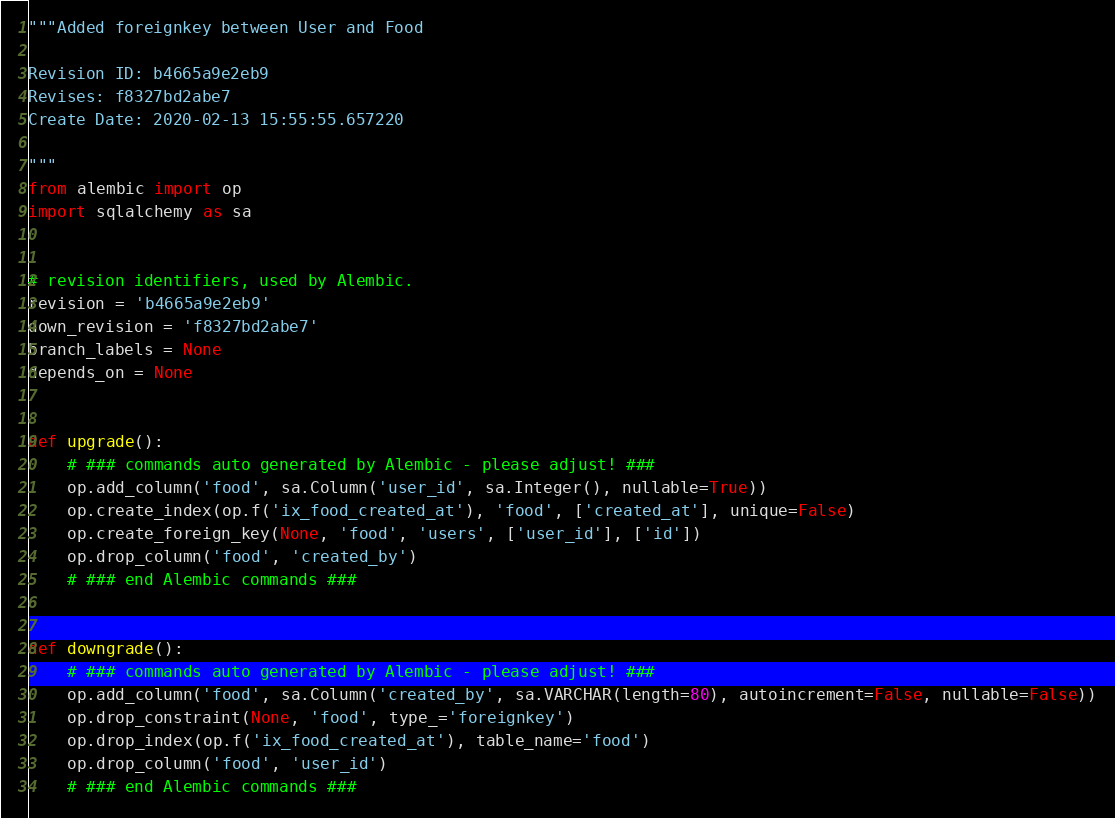<code> <loc_0><loc_0><loc_500><loc_500><_Python_>"""Added foreignkey between User and Food

Revision ID: b4665a9e2eb9
Revises: f8327bd2abe7
Create Date: 2020-02-13 15:55:55.657220

"""
from alembic import op
import sqlalchemy as sa


# revision identifiers, used by Alembic.
revision = 'b4665a9e2eb9'
down_revision = 'f8327bd2abe7'
branch_labels = None
depends_on = None


def upgrade():
    # ### commands auto generated by Alembic - please adjust! ###
    op.add_column('food', sa.Column('user_id', sa.Integer(), nullable=True))
    op.create_index(op.f('ix_food_created_at'), 'food', ['created_at'], unique=False)
    op.create_foreign_key(None, 'food', 'users', ['user_id'], ['id'])
    op.drop_column('food', 'created_by')
    # ### end Alembic commands ###


def downgrade():
    # ### commands auto generated by Alembic - please adjust! ###
    op.add_column('food', sa.Column('created_by', sa.VARCHAR(length=80), autoincrement=False, nullable=False))
    op.drop_constraint(None, 'food', type_='foreignkey')
    op.drop_index(op.f('ix_food_created_at'), table_name='food')
    op.drop_column('food', 'user_id')
    # ### end Alembic commands ###
</code> 